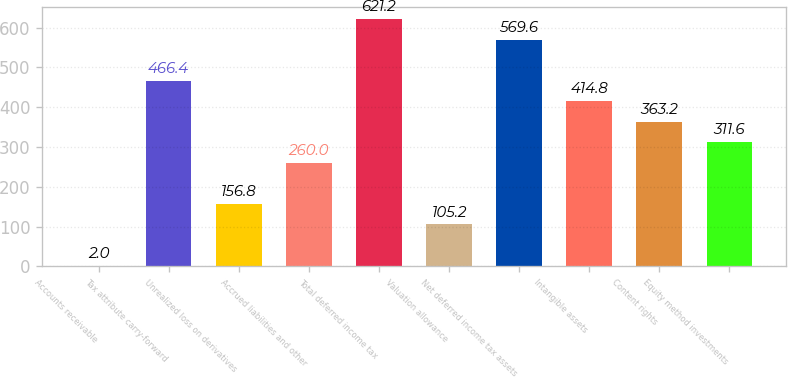<chart> <loc_0><loc_0><loc_500><loc_500><bar_chart><fcel>Accounts receivable<fcel>Tax attribute carry-forward<fcel>Unrealized loss on derivatives<fcel>Accrued liabilities and other<fcel>Total deferred income tax<fcel>Valuation allowance<fcel>Net deferred income tax assets<fcel>Intangible assets<fcel>Content rights<fcel>Equity method investments<nl><fcel>2<fcel>466.4<fcel>156.8<fcel>260<fcel>621.2<fcel>105.2<fcel>569.6<fcel>414.8<fcel>363.2<fcel>311.6<nl></chart> 